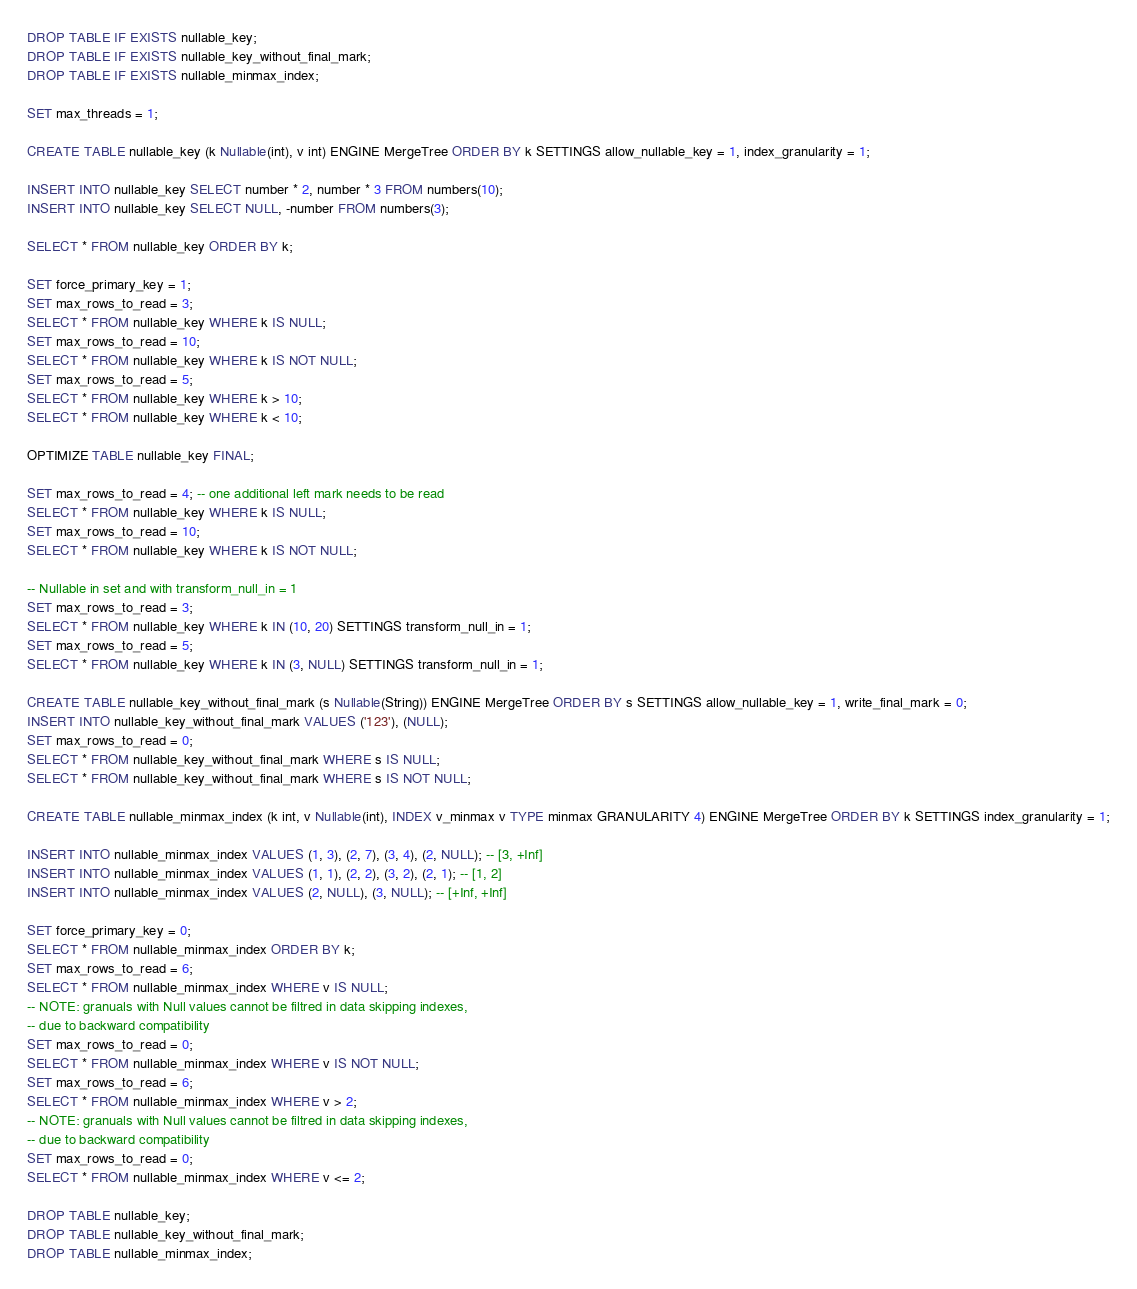Convert code to text. <code><loc_0><loc_0><loc_500><loc_500><_SQL_>DROP TABLE IF EXISTS nullable_key;
DROP TABLE IF EXISTS nullable_key_without_final_mark;
DROP TABLE IF EXISTS nullable_minmax_index;

SET max_threads = 1;

CREATE TABLE nullable_key (k Nullable(int), v int) ENGINE MergeTree ORDER BY k SETTINGS allow_nullable_key = 1, index_granularity = 1;

INSERT INTO nullable_key SELECT number * 2, number * 3 FROM numbers(10);
INSERT INTO nullable_key SELECT NULL, -number FROM numbers(3);

SELECT * FROM nullable_key ORDER BY k;

SET force_primary_key = 1;
SET max_rows_to_read = 3;
SELECT * FROM nullable_key WHERE k IS NULL;
SET max_rows_to_read = 10;
SELECT * FROM nullable_key WHERE k IS NOT NULL;
SET max_rows_to_read = 5;
SELECT * FROM nullable_key WHERE k > 10;
SELECT * FROM nullable_key WHERE k < 10;

OPTIMIZE TABLE nullable_key FINAL;

SET max_rows_to_read = 4; -- one additional left mark needs to be read
SELECT * FROM nullable_key WHERE k IS NULL;
SET max_rows_to_read = 10;
SELECT * FROM nullable_key WHERE k IS NOT NULL;

-- Nullable in set and with transform_null_in = 1
SET max_rows_to_read = 3;
SELECT * FROM nullable_key WHERE k IN (10, 20) SETTINGS transform_null_in = 1;
SET max_rows_to_read = 5;
SELECT * FROM nullable_key WHERE k IN (3, NULL) SETTINGS transform_null_in = 1;

CREATE TABLE nullable_key_without_final_mark (s Nullable(String)) ENGINE MergeTree ORDER BY s SETTINGS allow_nullable_key = 1, write_final_mark = 0;
INSERT INTO nullable_key_without_final_mark VALUES ('123'), (NULL);
SET max_rows_to_read = 0;
SELECT * FROM nullable_key_without_final_mark WHERE s IS NULL;
SELECT * FROM nullable_key_without_final_mark WHERE s IS NOT NULL;

CREATE TABLE nullable_minmax_index (k int, v Nullable(int), INDEX v_minmax v TYPE minmax GRANULARITY 4) ENGINE MergeTree ORDER BY k SETTINGS index_granularity = 1;

INSERT INTO nullable_minmax_index VALUES (1, 3), (2, 7), (3, 4), (2, NULL); -- [3, +Inf]
INSERT INTO nullable_minmax_index VALUES (1, 1), (2, 2), (3, 2), (2, 1); -- [1, 2]
INSERT INTO nullable_minmax_index VALUES (2, NULL), (3, NULL); -- [+Inf, +Inf]

SET force_primary_key = 0;
SELECT * FROM nullable_minmax_index ORDER BY k;
SET max_rows_to_read = 6;
SELECT * FROM nullable_minmax_index WHERE v IS NULL;
-- NOTE: granuals with Null values cannot be filtred in data skipping indexes,
-- due to backward compatibility
SET max_rows_to_read = 0;
SELECT * FROM nullable_minmax_index WHERE v IS NOT NULL;
SET max_rows_to_read = 6;
SELECT * FROM nullable_minmax_index WHERE v > 2;
-- NOTE: granuals with Null values cannot be filtred in data skipping indexes,
-- due to backward compatibility
SET max_rows_to_read = 0;
SELECT * FROM nullable_minmax_index WHERE v <= 2;

DROP TABLE nullable_key;
DROP TABLE nullable_key_without_final_mark;
DROP TABLE nullable_minmax_index;
</code> 